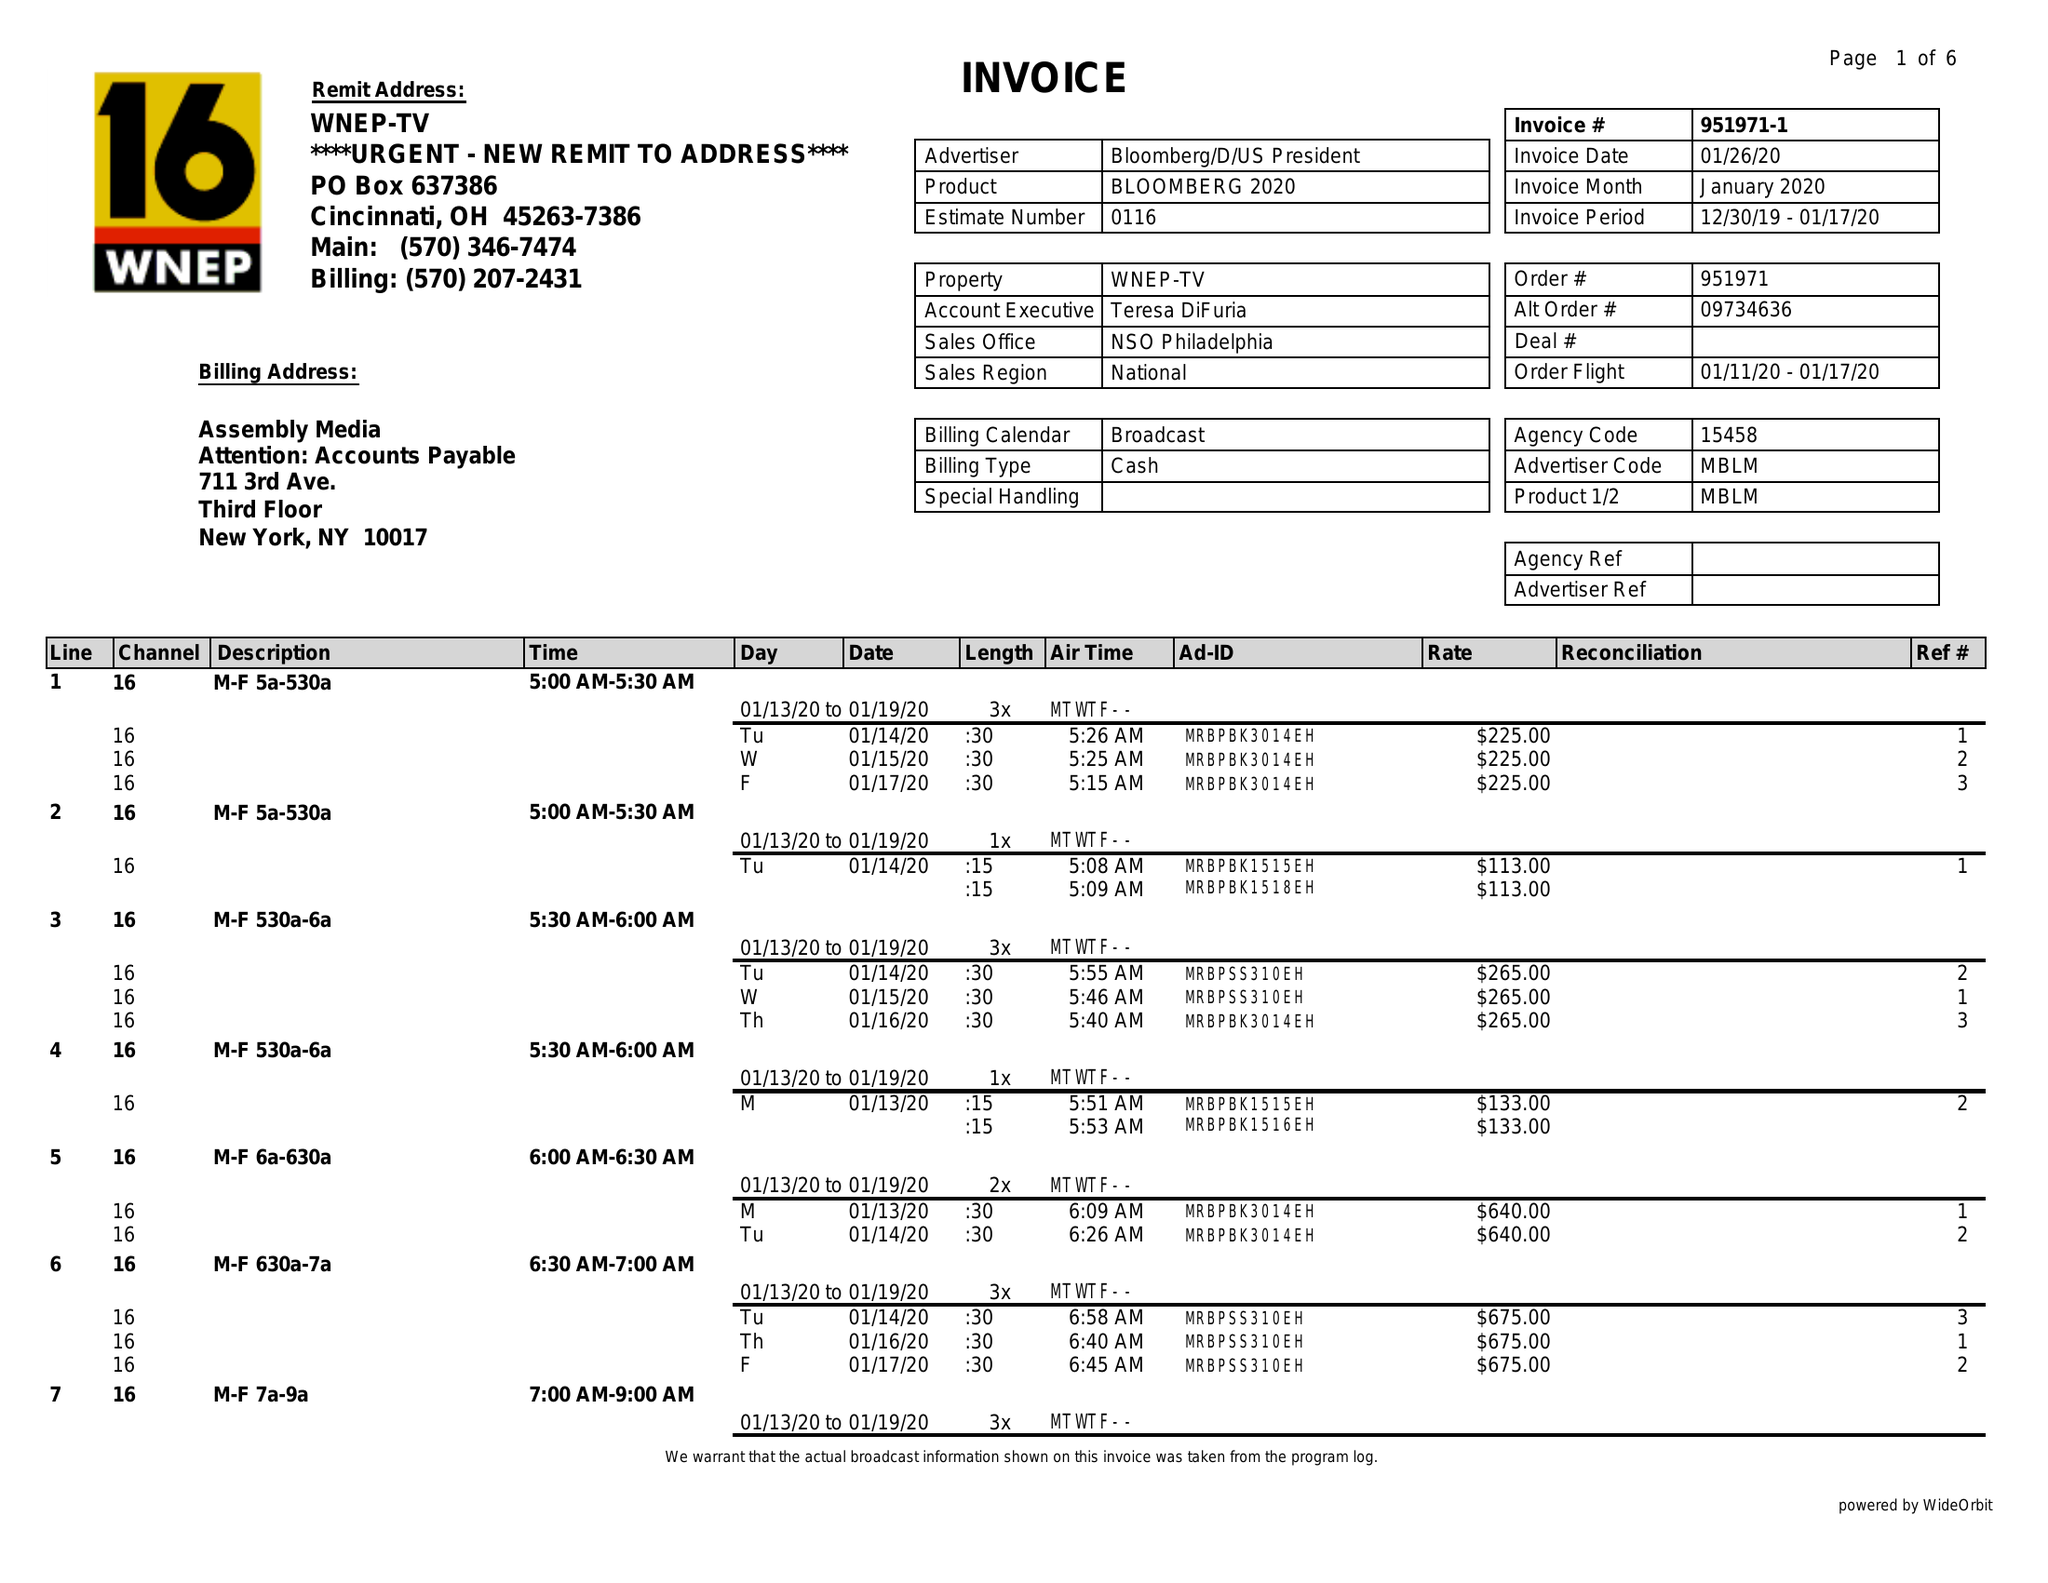What is the value for the gross_amount?
Answer the question using a single word or phrase. 30553.00 